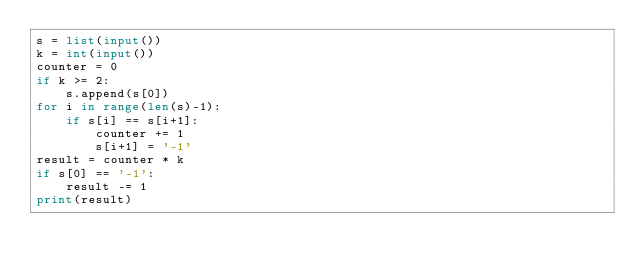<code> <loc_0><loc_0><loc_500><loc_500><_Python_>s = list(input())
k = int(input())
counter = 0
if k >= 2:
    s.append(s[0])
for i in range(len(s)-1):
    if s[i] == s[i+1]:
        counter += 1
        s[i+1] = '-1'
result = counter * k
if s[0] == '-1':
    result -= 1
print(result)</code> 